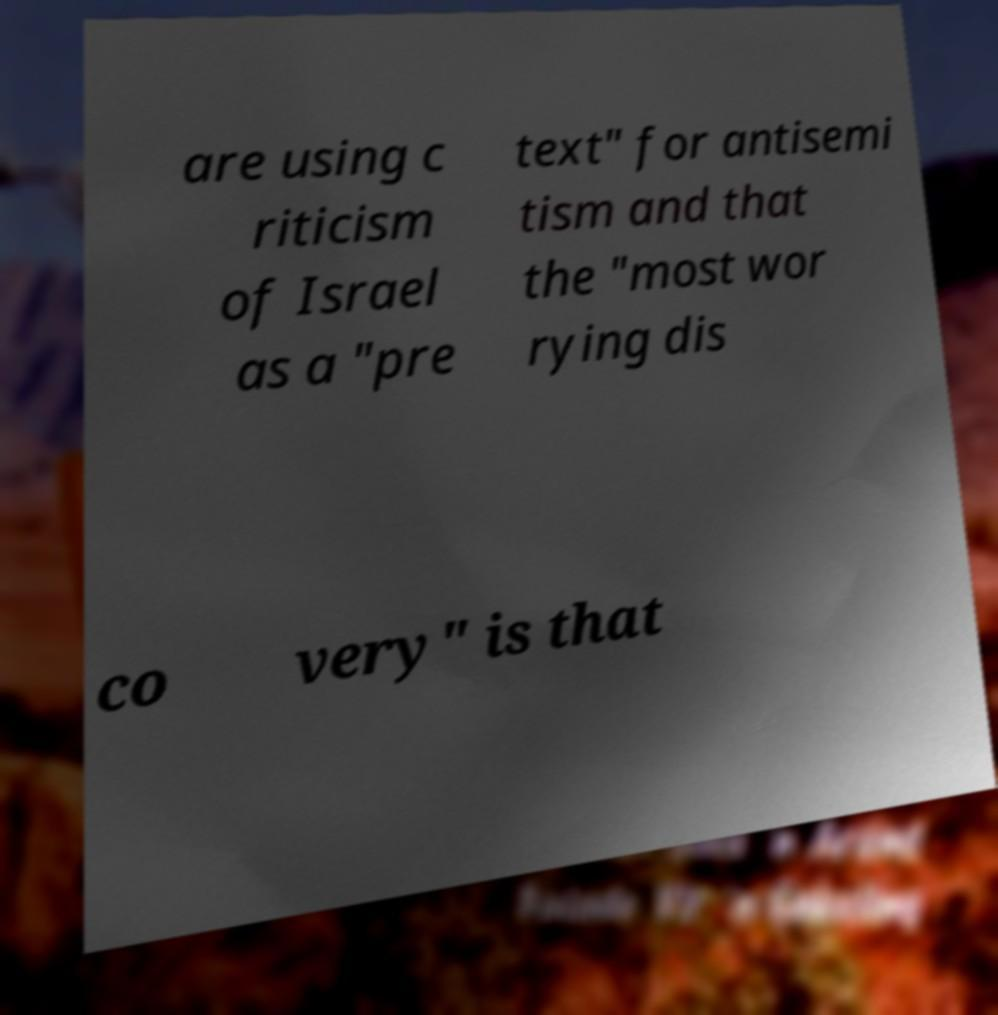Could you assist in decoding the text presented in this image and type it out clearly? are using c riticism of Israel as a "pre text" for antisemi tism and that the "most wor rying dis co very" is that 